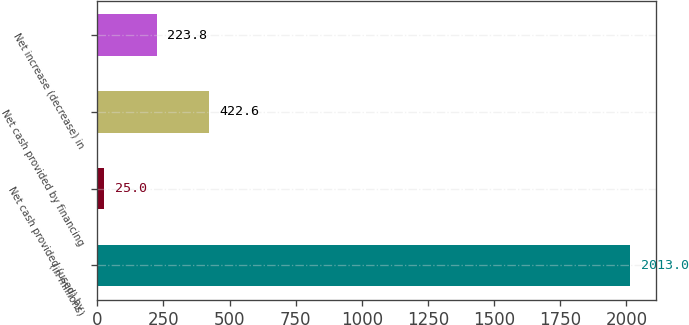Convert chart. <chart><loc_0><loc_0><loc_500><loc_500><bar_chart><fcel>(in millions)<fcel>Net cash provided (used) by<fcel>Net cash provided by financing<fcel>Net increase (decrease) in<nl><fcel>2013<fcel>25<fcel>422.6<fcel>223.8<nl></chart> 